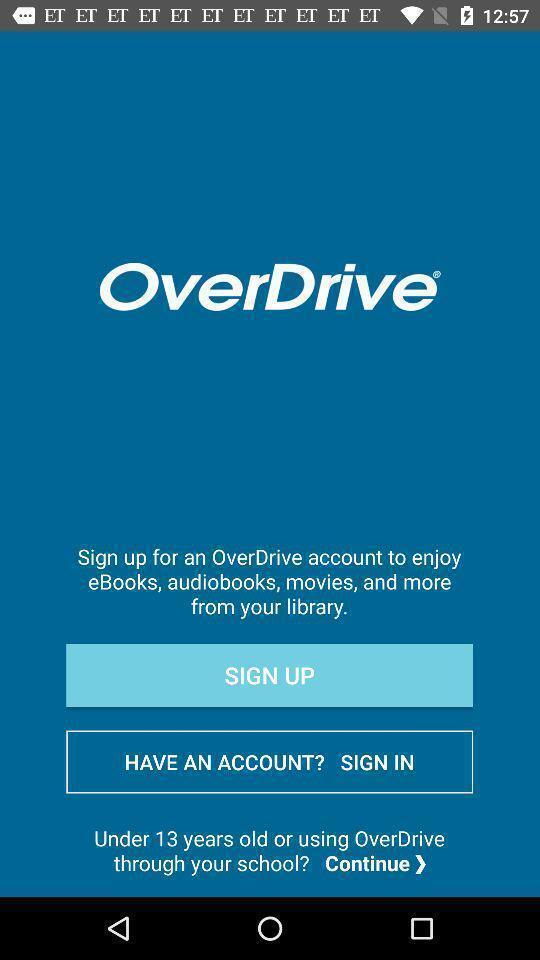What details can you identify in this image? Welcome page for a online library app. 